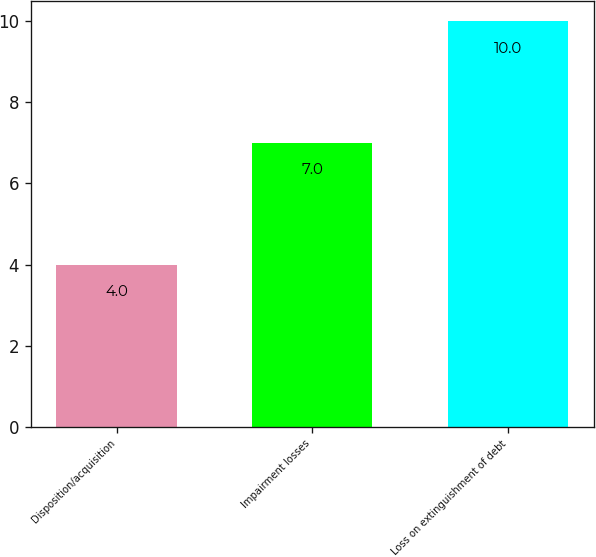Convert chart. <chart><loc_0><loc_0><loc_500><loc_500><bar_chart><fcel>Disposition/acquisition<fcel>Impairment losses<fcel>Loss on extinguishment of debt<nl><fcel>4<fcel>7<fcel>10<nl></chart> 